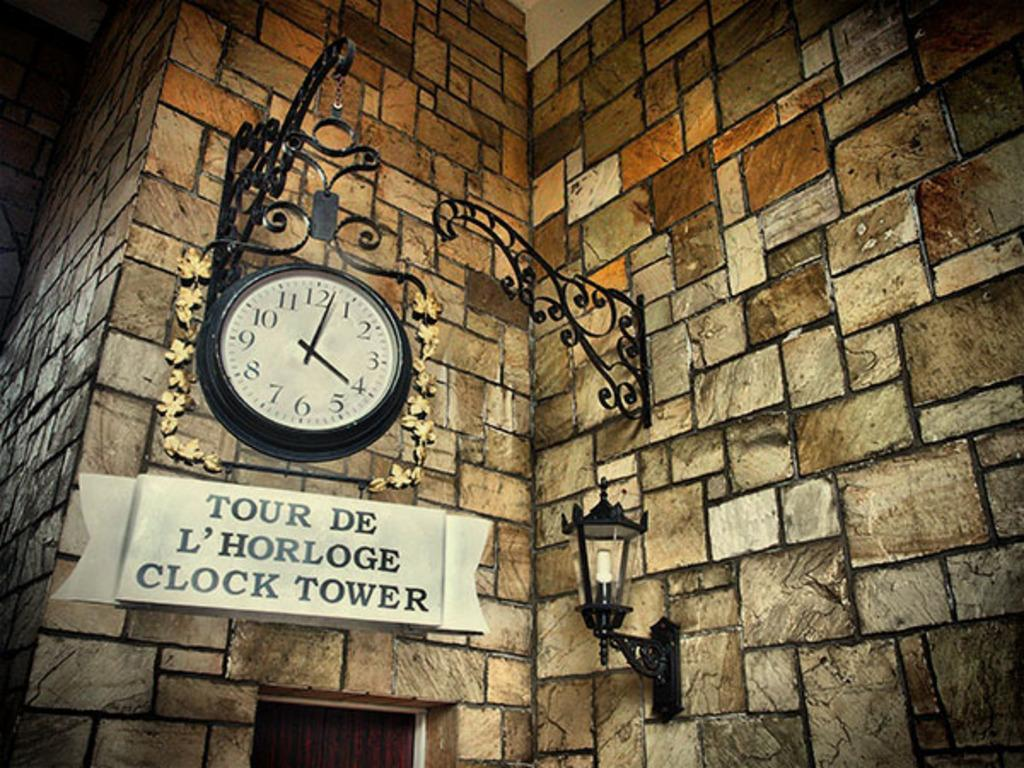<image>
Give a short and clear explanation of the subsequent image. Buliding with a white sign which says "Tour De L'Horloge Clock Tower" on it. 